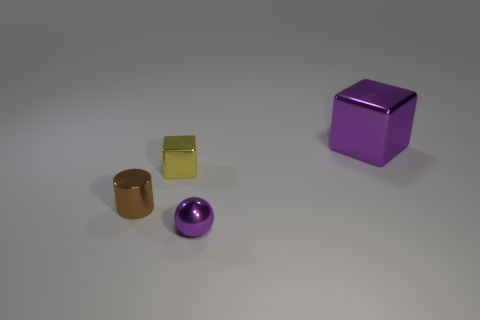Are there any brown objects that have the same size as the yellow block?
Keep it short and to the point. Yes. There is a small object that is behind the tiny brown metal cylinder; is it the same color as the tiny cylinder?
Your answer should be very brief. No. What is the size of the brown metallic cylinder?
Make the answer very short. Small. There is a purple metal thing to the left of the metallic cube that is to the right of the small metal cube; how big is it?
Your answer should be compact. Small. How many metallic cylinders are the same color as the tiny ball?
Your answer should be very brief. 0. How many purple blocks are there?
Your answer should be compact. 1. How many brown objects have the same material as the tiny yellow cube?
Your answer should be compact. 1. What is the size of the other object that is the same shape as the big purple shiny thing?
Your answer should be compact. Small. What is the material of the small yellow object?
Provide a succinct answer. Metal. What is the material of the purple thing that is behind the cube in front of the purple metallic object on the right side of the sphere?
Offer a very short reply. Metal. 